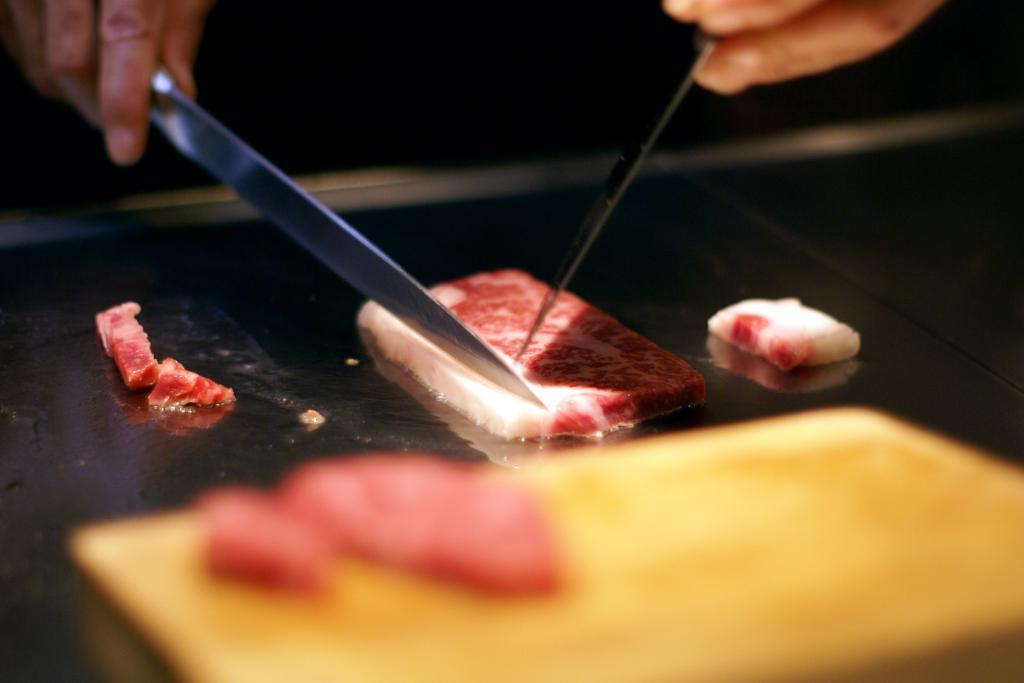Could you give a brief overview of what you see in this image? In this picture I can observe a piece of bread on the black color surface. There are two knives in the human hands in this picture. 